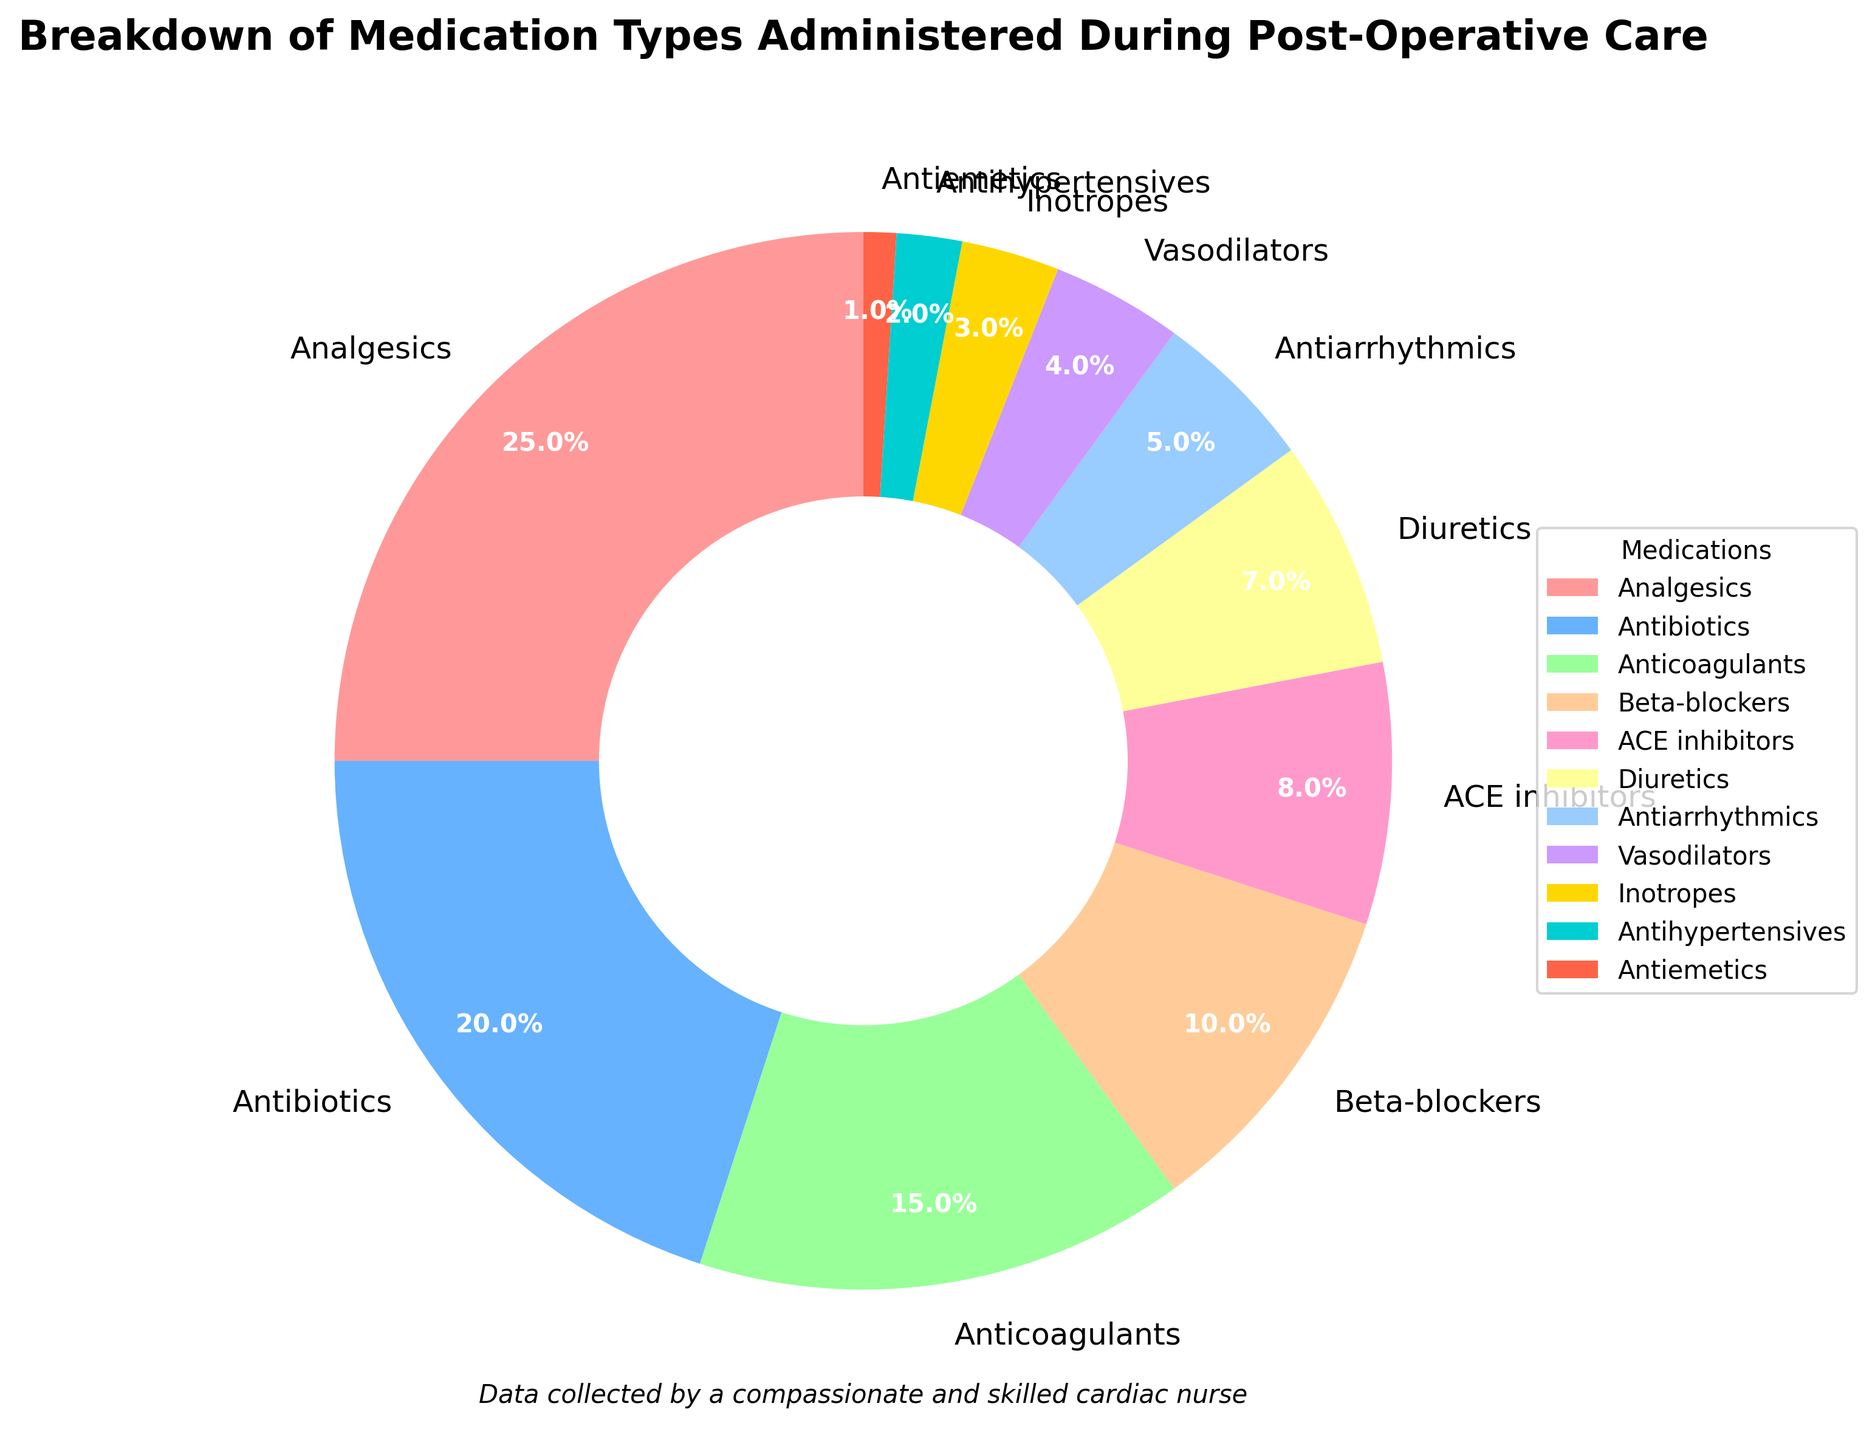Which medication type has the highest percentage in the chart? Check the section with the largest portion in the pie chart and refer to the label associated with it. Here, the Analgesics segment is the largest at 25%.
Answer: Analgesics What is the combined percentage of Antibiotics and Anticoagulants? Find and sum the percentages for Antibiotics (20%) and Anticoagulants (15%). 20% + 15% equals 35%.
Answer: 35% Which medication type has the smallest percentage and what is it? Identify the smallest segment in the pie chart and check the label: The Antiemetics segment is the smallest with a 1% share.
Answer: Antiemetics, 1% Are Beta-blockers used more frequently than ACE inhibitors? Compare the percentages for Beta-blockers (10%) and ACE inhibitors (8%). Since 10% is greater than 8%, Beta-blockers are used more frequently.
Answer: Yes What fraction of the total medication is represented by Vasodilators and Inotropes combined? Add the percentages of Vasodilators (4%) and Inotropes (3%) to get 7%. The fraction is 7/100, which simplifies to 7%.
Answer: 7% How much more frequently are Analgesics administered compared to Antihypertensives? Subtract the percentage of Antihypertensives (2%) from the percentage of Analgesics (25%). The difference is 25% - 2% = 23%.
Answer: 23% What is the sum of the percentages of medications that have a single-digit percentage share? Add the percentages of ACE inhibitors (8%), Diuretics (7%), Antiarrhythmics (5%), Vasodilators (4%), Inotropes (3%), Antihypertensives (2%), and Antiemetics (1%). The sum is 8% + 7% + 5% + 4% + 3% + 2% + 1% = 30%.
Answer: 30% Is the percentage of Diuretics higher than Antiarrhythmics? Compare the percentages of Diuretics (7%) and Antiarrhythmics (5%). Since 7% is greater than 5%, Diuretics are higher.
Answer: Yes Which color represents Antibiotics, and what is their percentage? Locate the color for Antibiotics (which is the second segment from the top) and check the label for its percentage, which is 20%. This is shown in a blue-like color.
Answer: Blue-like, 20% What is the percentage difference between Anticoagulants and Diuretics? Subtract the Diuretics percentage (7%) from Anticoagulants percentage (15%). The difference is 15% - 7% = 8%.
Answer: 8% 